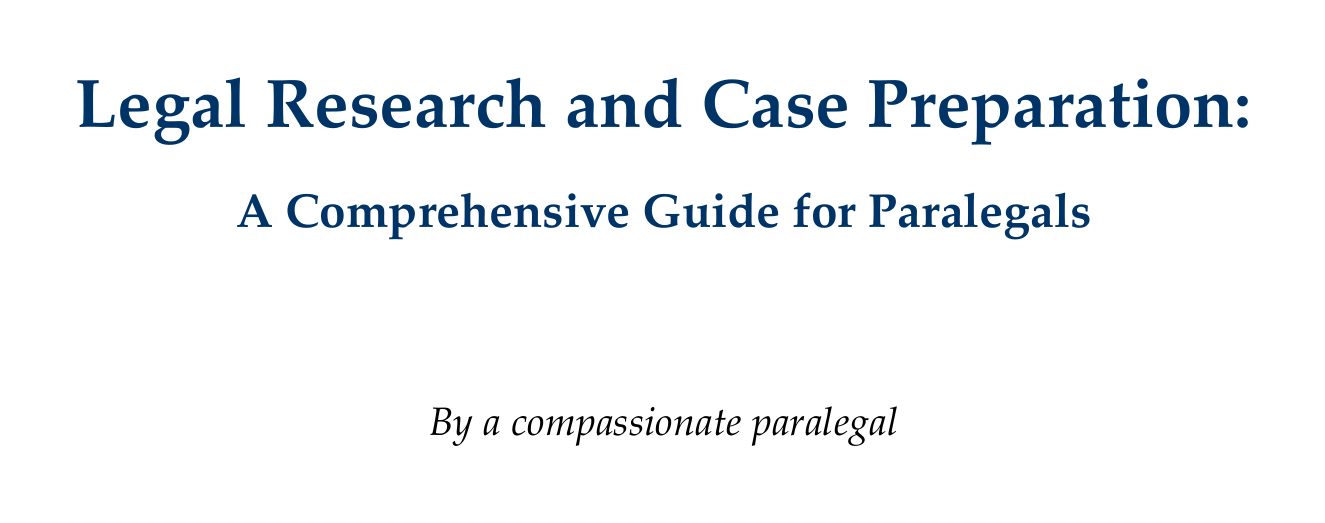What is the title of the manual? The title of the manual is stated in the title page section of the document.
Answer: Legal Research and Case Preparation: A Comprehensive Guide for Paralegals What are the two types of sources mentioned in the section on legal research? The document lists primary sources and secondary sources in the relevant chapter.
Answer: Primary sources and secondary sources Which online legal research platforms are highlighted? The manual specifies three online platforms in the section dedicated to online resources.
Answer: Westlaw, LexisNexis, and Bloomberg Law What is emphasized in the section on client interviews? The focus area in the section about client interviews involves a specific interviewing technique.
Answer: Active listening What tool is recommended for timeline creation? The document names a software that helps in visually representing case events in the timeline creation section.
Answer: TimelineJS or Aeon Timeline What is Rule 1.6 related to in the ethical considerations chapter? The document outlines the importance of a specific rule concerning client confidentiality.
Answer: Confidentiality of Information What should be developed to effectively communicate with attorneys? The manual discusses a skill that is crucial for sharing research findings and case updates.
Answer: Strong communication skills How can paralegals manage expectations regarding tasks? The document suggests a method for handling timelines concerning research and preparation tasks.
Answer: Provide realistic timelines 